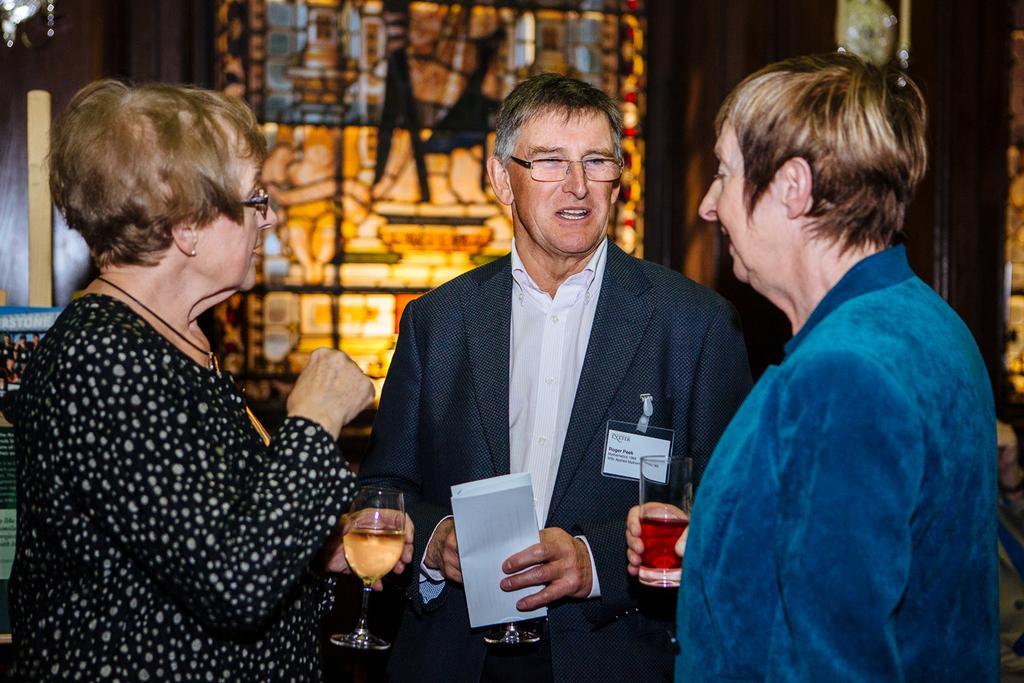How would you summarize this image in a sentence or two? In this picture I can observe three members in the middle of the picture. All of them are holding glasses in their hands. The background is blurred. 